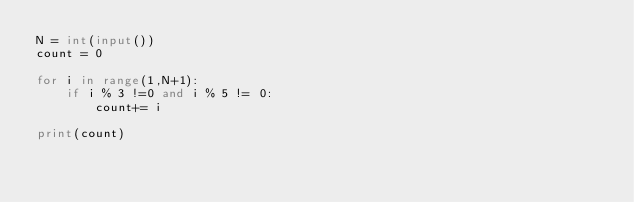<code> <loc_0><loc_0><loc_500><loc_500><_Python_>N = int(input())
count = 0

for i in range(1,N+1):
    if i % 3 !=0 and i % 5 != 0:
        count+= i

print(count)</code> 